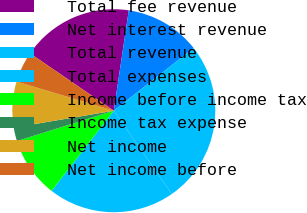<chart> <loc_0><loc_0><loc_500><loc_500><pie_chart><fcel>Total fee revenue<fcel>Net interest revenue<fcel>Total revenue<fcel>Total expenses<fcel>Income before income tax<fcel>Income tax expense<fcel>Net income<fcel>Net income before<nl><fcel>17.8%<fcel>12.05%<fcel>25.92%<fcel>20.18%<fcel>9.67%<fcel>2.17%<fcel>7.3%<fcel>4.92%<nl></chart> 